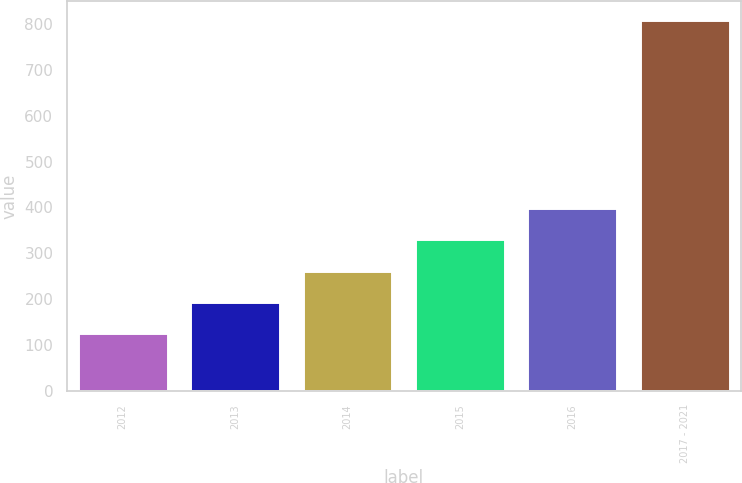Convert chart. <chart><loc_0><loc_0><loc_500><loc_500><bar_chart><fcel>2012<fcel>2013<fcel>2014<fcel>2015<fcel>2016<fcel>2017 - 2021<nl><fcel>125<fcel>193.5<fcel>262<fcel>330.5<fcel>399<fcel>810<nl></chart> 